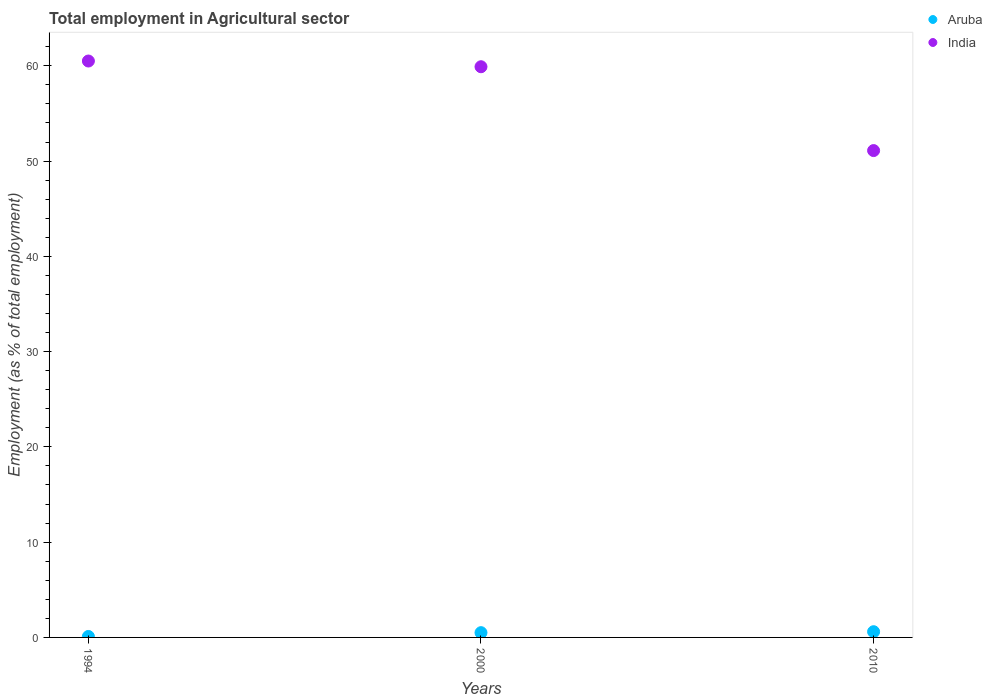What is the employment in agricultural sector in Aruba in 2010?
Your answer should be compact. 0.6. Across all years, what is the maximum employment in agricultural sector in India?
Keep it short and to the point. 60.5. Across all years, what is the minimum employment in agricultural sector in Aruba?
Your answer should be very brief. 0.1. In which year was the employment in agricultural sector in India minimum?
Give a very brief answer. 2010. What is the total employment in agricultural sector in Aruba in the graph?
Offer a very short reply. 1.2. What is the difference between the employment in agricultural sector in Aruba in 1994 and that in 2000?
Offer a terse response. -0.4. What is the difference between the employment in agricultural sector in India in 1994 and the employment in agricultural sector in Aruba in 2010?
Offer a very short reply. 59.9. What is the average employment in agricultural sector in India per year?
Give a very brief answer. 57.17. In the year 1994, what is the difference between the employment in agricultural sector in India and employment in agricultural sector in Aruba?
Offer a very short reply. 60.4. In how many years, is the employment in agricultural sector in Aruba greater than 20 %?
Make the answer very short. 0. What is the ratio of the employment in agricultural sector in Aruba in 2000 to that in 2010?
Give a very brief answer. 0.83. What is the difference between the highest and the second highest employment in agricultural sector in India?
Offer a terse response. 0.6. What is the difference between the highest and the lowest employment in agricultural sector in Aruba?
Keep it short and to the point. 0.5. In how many years, is the employment in agricultural sector in Aruba greater than the average employment in agricultural sector in Aruba taken over all years?
Give a very brief answer. 2. Does the employment in agricultural sector in Aruba monotonically increase over the years?
Ensure brevity in your answer.  Yes. How many years are there in the graph?
Your answer should be compact. 3. Does the graph contain any zero values?
Make the answer very short. No. Does the graph contain grids?
Your answer should be compact. No. How are the legend labels stacked?
Your answer should be very brief. Vertical. What is the title of the graph?
Provide a short and direct response. Total employment in Agricultural sector. Does "Congo (Democratic)" appear as one of the legend labels in the graph?
Provide a short and direct response. No. What is the label or title of the X-axis?
Your answer should be very brief. Years. What is the label or title of the Y-axis?
Your answer should be compact. Employment (as % of total employment). What is the Employment (as % of total employment) of Aruba in 1994?
Your answer should be compact. 0.1. What is the Employment (as % of total employment) in India in 1994?
Your answer should be very brief. 60.5. What is the Employment (as % of total employment) in Aruba in 2000?
Provide a succinct answer. 0.5. What is the Employment (as % of total employment) in India in 2000?
Ensure brevity in your answer.  59.9. What is the Employment (as % of total employment) in Aruba in 2010?
Your response must be concise. 0.6. What is the Employment (as % of total employment) of India in 2010?
Offer a terse response. 51.1. Across all years, what is the maximum Employment (as % of total employment) of Aruba?
Give a very brief answer. 0.6. Across all years, what is the maximum Employment (as % of total employment) in India?
Your answer should be compact. 60.5. Across all years, what is the minimum Employment (as % of total employment) of Aruba?
Your answer should be very brief. 0.1. Across all years, what is the minimum Employment (as % of total employment) of India?
Your answer should be very brief. 51.1. What is the total Employment (as % of total employment) of India in the graph?
Offer a terse response. 171.5. What is the difference between the Employment (as % of total employment) in India in 2000 and that in 2010?
Ensure brevity in your answer.  8.8. What is the difference between the Employment (as % of total employment) of Aruba in 1994 and the Employment (as % of total employment) of India in 2000?
Offer a very short reply. -59.8. What is the difference between the Employment (as % of total employment) of Aruba in 1994 and the Employment (as % of total employment) of India in 2010?
Ensure brevity in your answer.  -51. What is the difference between the Employment (as % of total employment) in Aruba in 2000 and the Employment (as % of total employment) in India in 2010?
Offer a terse response. -50.6. What is the average Employment (as % of total employment) in India per year?
Your response must be concise. 57.17. In the year 1994, what is the difference between the Employment (as % of total employment) of Aruba and Employment (as % of total employment) of India?
Offer a very short reply. -60.4. In the year 2000, what is the difference between the Employment (as % of total employment) of Aruba and Employment (as % of total employment) of India?
Give a very brief answer. -59.4. In the year 2010, what is the difference between the Employment (as % of total employment) in Aruba and Employment (as % of total employment) in India?
Provide a short and direct response. -50.5. What is the ratio of the Employment (as % of total employment) in Aruba in 1994 to that in 2010?
Offer a terse response. 0.17. What is the ratio of the Employment (as % of total employment) of India in 1994 to that in 2010?
Ensure brevity in your answer.  1.18. What is the ratio of the Employment (as % of total employment) in India in 2000 to that in 2010?
Your answer should be very brief. 1.17. What is the difference between the highest and the second highest Employment (as % of total employment) in India?
Offer a very short reply. 0.6. 